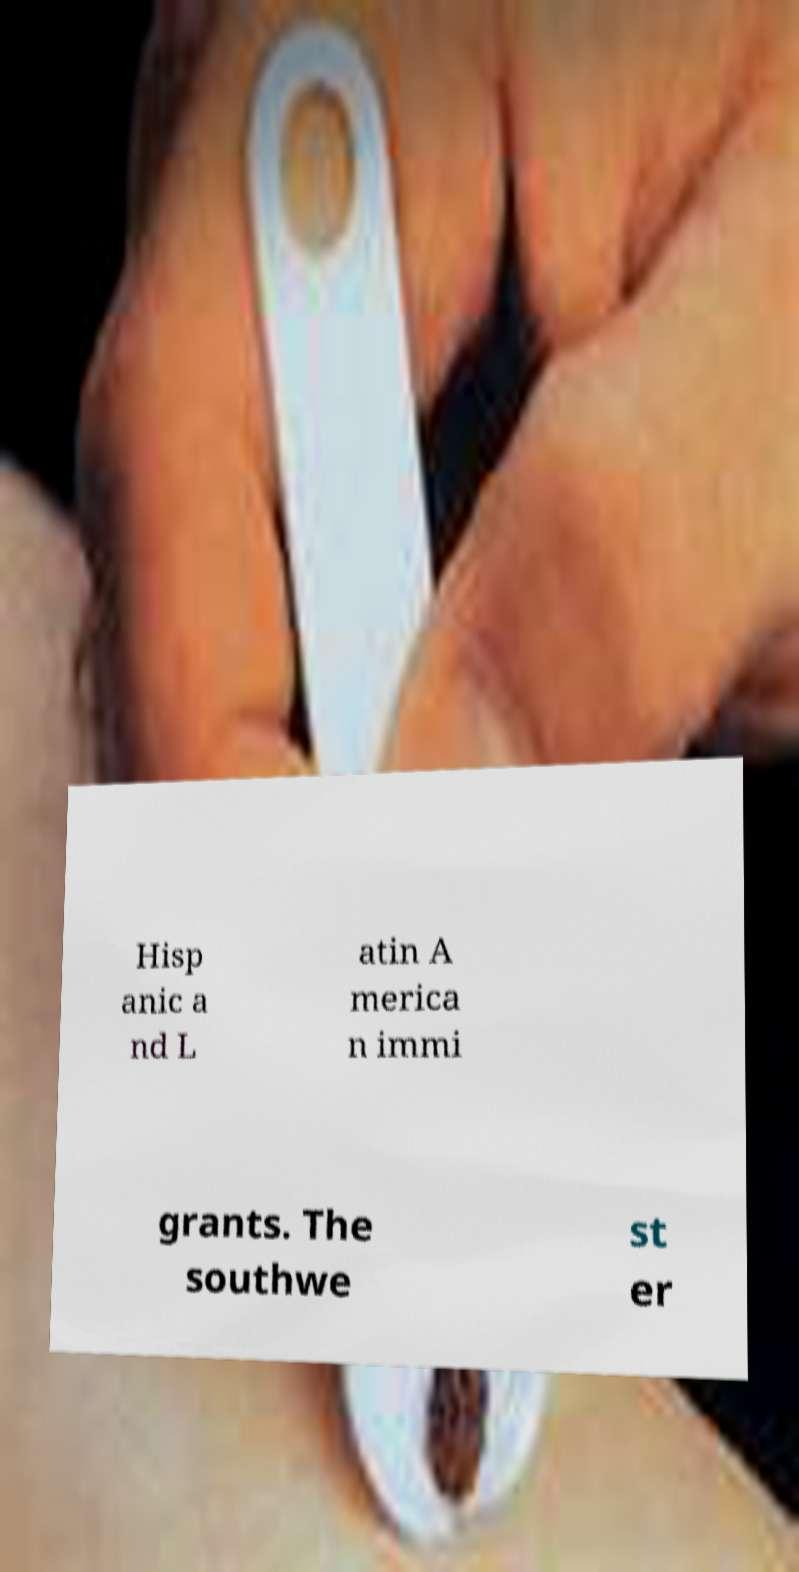What messages or text are displayed in this image? I need them in a readable, typed format. Hisp anic a nd L atin A merica n immi grants. The southwe st er 